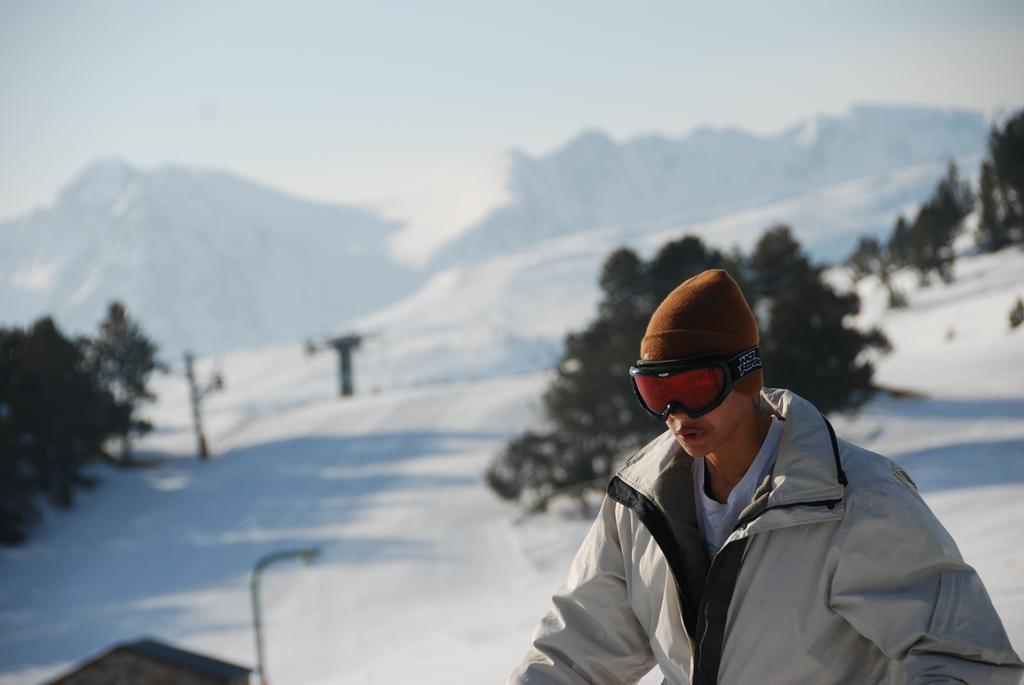Could you give a brief overview of what you see in this image? On the right side, there is a person in a gray color jacket, wearing a brown color cap and sunglasses. In the background, there are trees on a snow surface, there are mountains and there are clouds in the sky. 